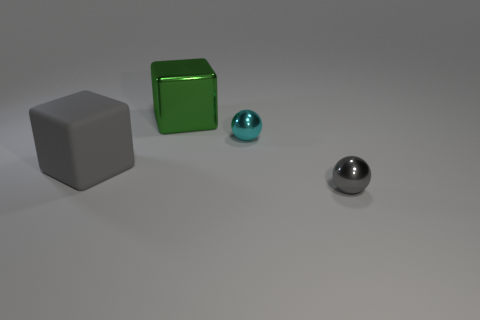How many things are small gray metallic things or gray things right of the green thing?
Ensure brevity in your answer.  1. Is the number of large shiny cubes behind the large gray cube less than the number of cyan metal cylinders?
Make the answer very short. No. There is a metallic thing behind the small object to the left of the tiny ball to the right of the small cyan ball; how big is it?
Your response must be concise. Large. There is a metal thing that is both behind the large matte object and on the right side of the green thing; what color is it?
Your response must be concise. Cyan. What number of purple balls are there?
Offer a terse response. 0. Are there any other things that are the same size as the green thing?
Give a very brief answer. Yes. Is the cyan object made of the same material as the gray ball?
Your response must be concise. Yes. There is a gray shiny ball to the right of the cyan ball; does it have the same size as the cyan metal ball that is to the right of the big shiny cube?
Provide a succinct answer. Yes. Are there fewer small cyan shiny spheres than big objects?
Ensure brevity in your answer.  Yes. What number of rubber objects are gray balls or green things?
Provide a short and direct response. 0. 